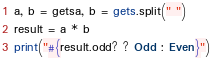<code> <loc_0><loc_0><loc_500><loc_500><_Ruby_>a, b = getsa, b = gets.split(" ")
result = a * b
print("#{result.odd? ? Odd : Even}")
</code> 